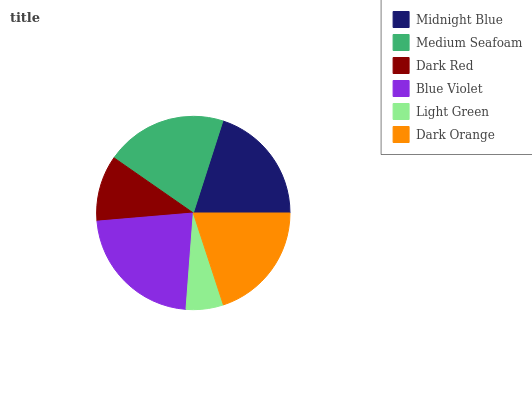Is Light Green the minimum?
Answer yes or no. Yes. Is Blue Violet the maximum?
Answer yes or no. Yes. Is Medium Seafoam the minimum?
Answer yes or no. No. Is Medium Seafoam the maximum?
Answer yes or no. No. Is Medium Seafoam greater than Midnight Blue?
Answer yes or no. Yes. Is Midnight Blue less than Medium Seafoam?
Answer yes or no. Yes. Is Midnight Blue greater than Medium Seafoam?
Answer yes or no. No. Is Medium Seafoam less than Midnight Blue?
Answer yes or no. No. Is Midnight Blue the high median?
Answer yes or no. Yes. Is Dark Orange the low median?
Answer yes or no. Yes. Is Light Green the high median?
Answer yes or no. No. Is Midnight Blue the low median?
Answer yes or no. No. 